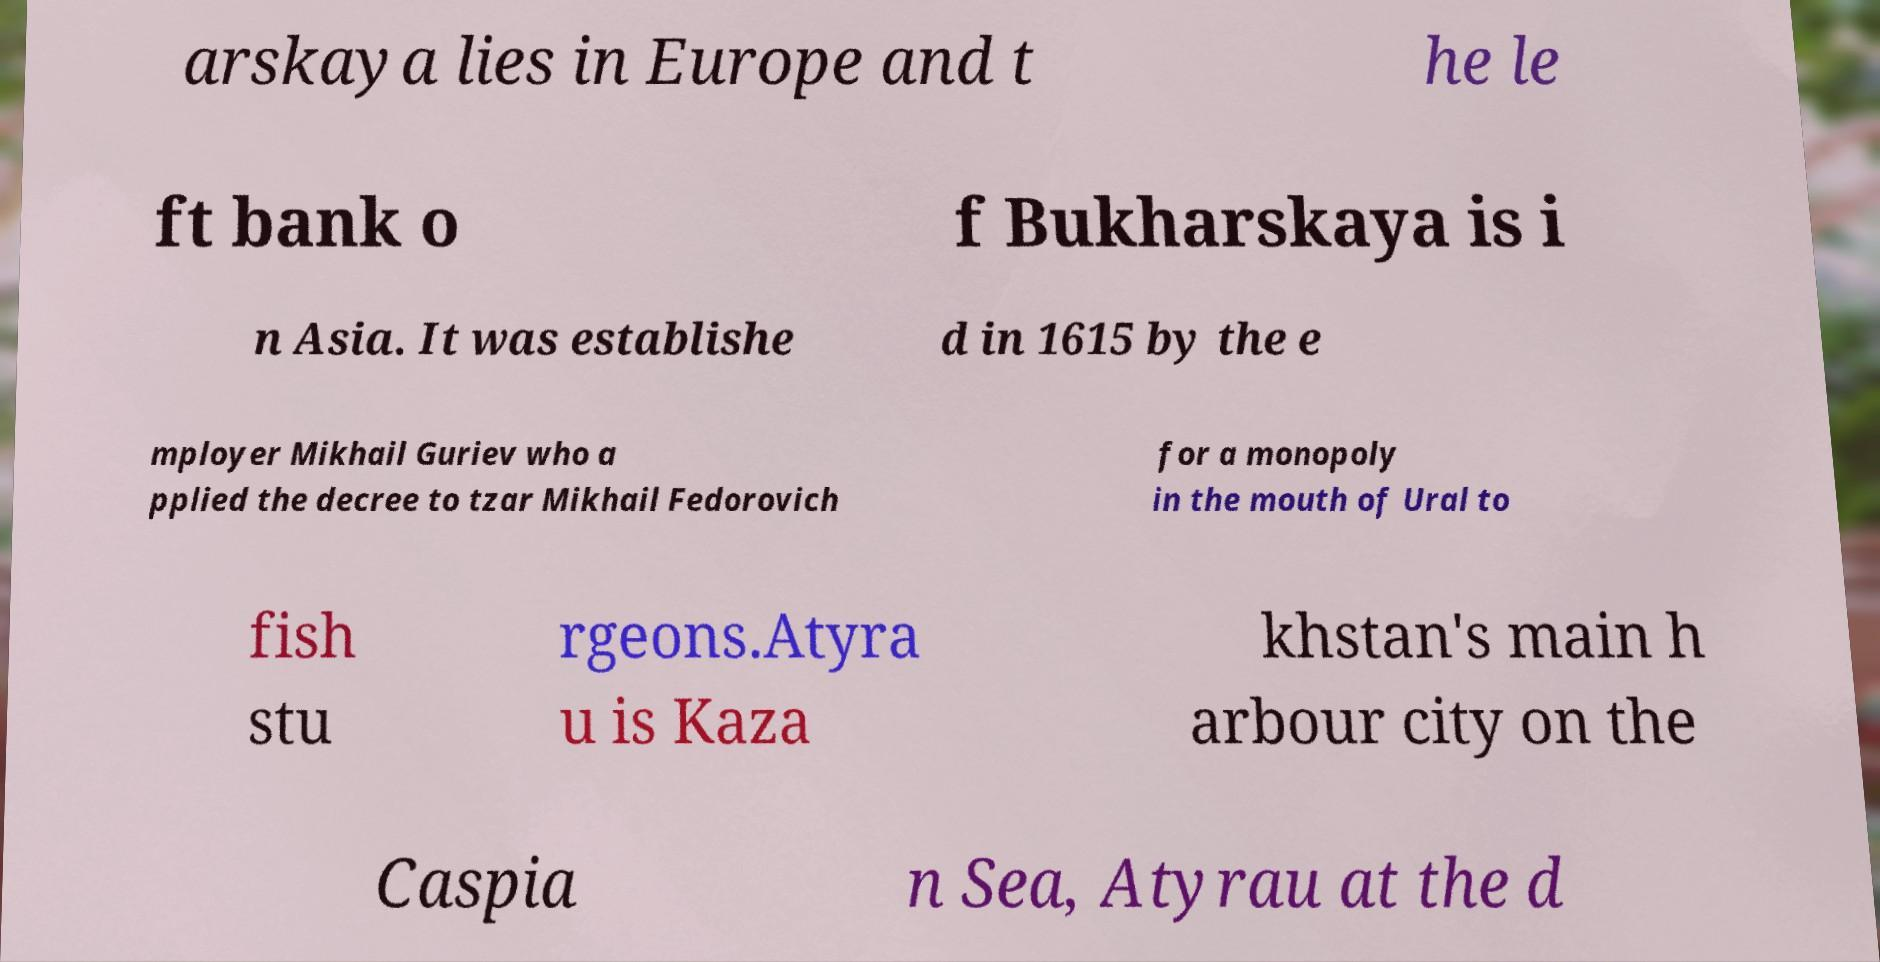Can you read and provide the text displayed in the image?This photo seems to have some interesting text. Can you extract and type it out for me? arskaya lies in Europe and t he le ft bank o f Bukharskaya is i n Asia. It was establishe d in 1615 by the e mployer Mikhail Guriev who a pplied the decree to tzar Mikhail Fedorovich for a monopoly in the mouth of Ural to fish stu rgeons.Atyra u is Kaza khstan's main h arbour city on the Caspia n Sea, Atyrau at the d 